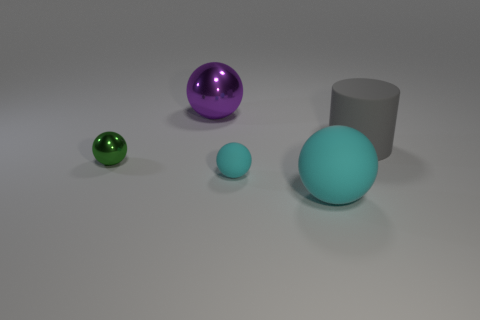What is the material of the other object that is the same color as the small matte thing?
Ensure brevity in your answer.  Rubber. Are there any small objects that are on the left side of the cyan matte thing behind the large cyan matte ball?
Offer a very short reply. Yes. What number of objects are either spheres that are behind the gray object or large blue rubber things?
Offer a terse response. 1. What is the material of the big ball behind the tiny sphere that is on the left side of the purple metal thing?
Your answer should be compact. Metal. Are there the same number of large gray rubber things in front of the large matte cylinder and gray matte cylinders that are left of the small cyan ball?
Keep it short and to the point. Yes. What number of objects are either matte things in front of the rubber cylinder or big balls right of the purple metallic thing?
Give a very brief answer. 2. There is a sphere that is on the left side of the small cyan rubber ball and in front of the purple shiny ball; what material is it?
Offer a very short reply. Metal. What size is the gray rubber thing right of the large purple metal thing to the right of the thing that is on the left side of the purple object?
Provide a short and direct response. Large. Are there more small green shiny things than tiny matte blocks?
Make the answer very short. Yes. Is the tiny thing that is to the left of the purple thing made of the same material as the large cylinder?
Keep it short and to the point. No. 